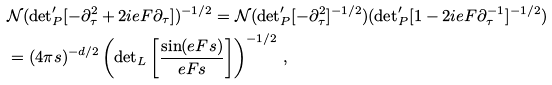<formula> <loc_0><loc_0><loc_500><loc_500>& \mathcal { N } ( { \det } ^ { \prime } _ { P } [ - \partial _ { \tau } ^ { 2 } + 2 i e F \partial _ { \tau } ] ) ^ { - 1 / 2 } = \mathcal { N } ( { \det } ^ { \prime } _ { P } [ - \partial _ { \tau } ^ { 2 } ] ^ { - 1 / 2 } ) ( { \det } ^ { \prime } _ { P } [ 1 - 2 i e F \partial _ { \tau } ^ { - 1 } ] ^ { - 1 / 2 } ) \\ & = ( 4 \pi s ) ^ { - d / 2 } \left ( { \det } _ { L } \left [ \frac { \sin ( e F s ) } { e F s } \right ] \right ) ^ { - 1 / 2 } \, ,</formula> 